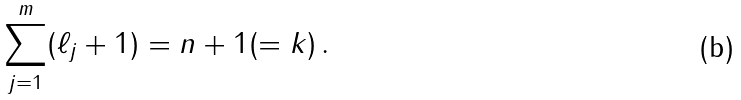Convert formula to latex. <formula><loc_0><loc_0><loc_500><loc_500>\sum _ { j = 1 } ^ { m } ( \ell _ { j } + 1 ) = n + 1 ( = k ) \, .</formula> 